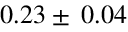<formula> <loc_0><loc_0><loc_500><loc_500>0 . 2 3 \pm \, 0 . 0 4</formula> 